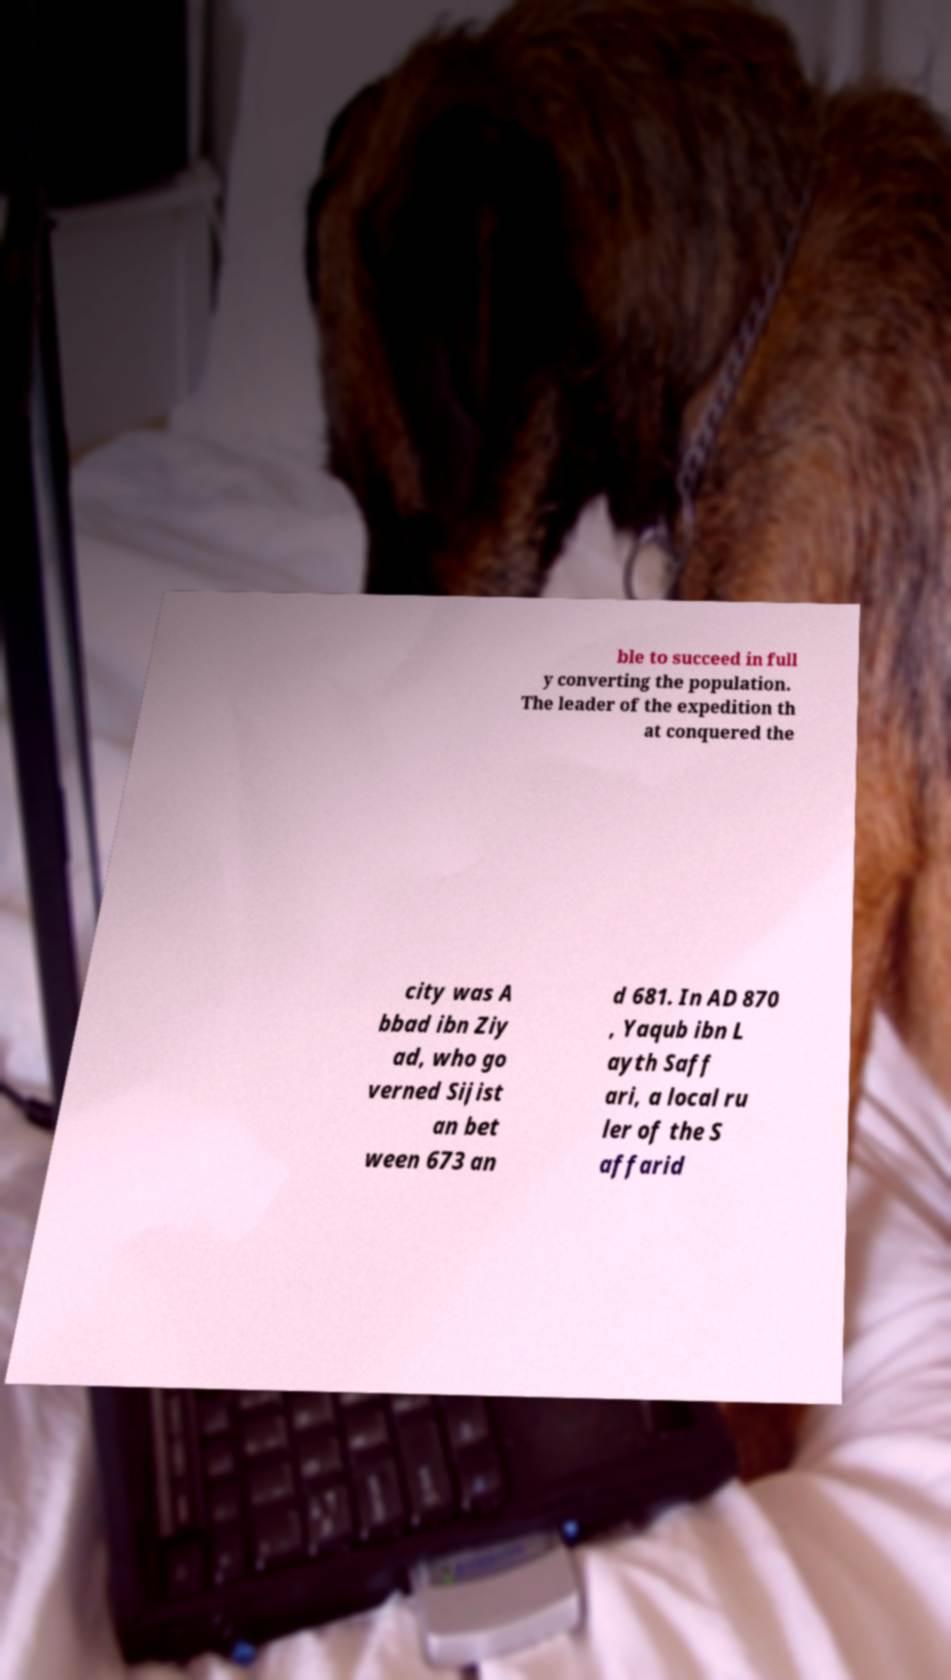There's text embedded in this image that I need extracted. Can you transcribe it verbatim? ble to succeed in full y converting the population. The leader of the expedition th at conquered the city was A bbad ibn Ziy ad, who go verned Sijist an bet ween 673 an d 681. In AD 870 , Yaqub ibn L ayth Saff ari, a local ru ler of the S affarid 